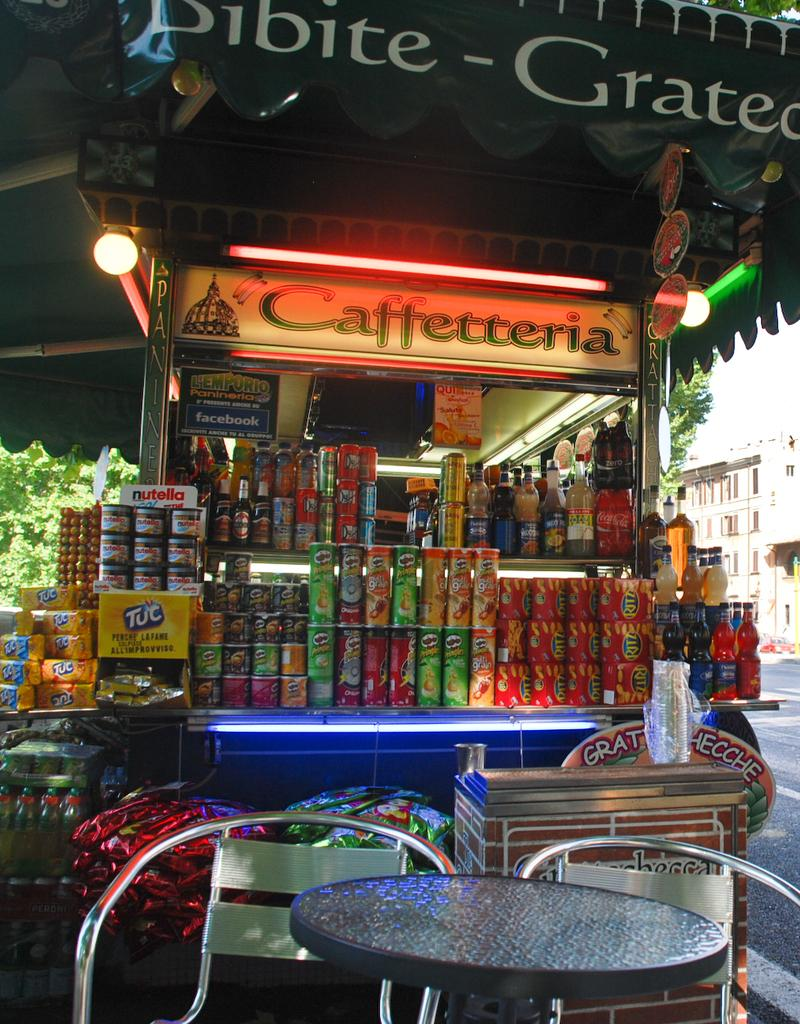<image>
Create a compact narrative representing the image presented. Snacks like Pringles and Nutella are stacked on display in the Caffetteria. 